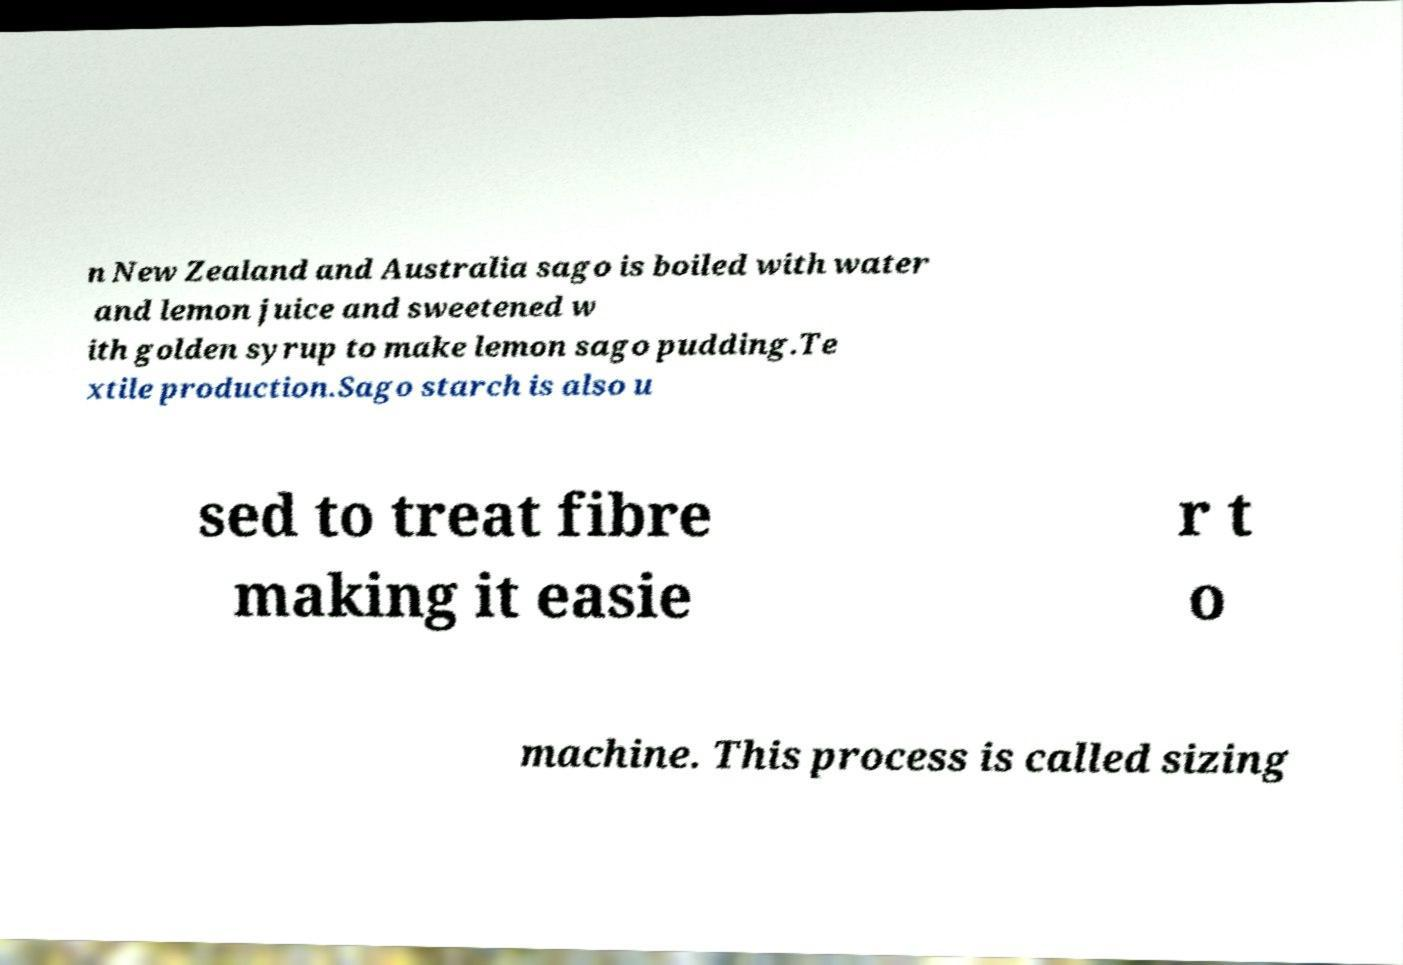I need the written content from this picture converted into text. Can you do that? n New Zealand and Australia sago is boiled with water and lemon juice and sweetened w ith golden syrup to make lemon sago pudding.Te xtile production.Sago starch is also u sed to treat fibre making it easie r t o machine. This process is called sizing 